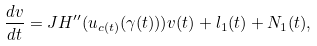Convert formula to latex. <formula><loc_0><loc_0><loc_500><loc_500>\frac { d v } { d t } = J H ^ { \prime \prime } ( u _ { c ( t ) } ( \gamma ( t ) ) ) v ( t ) + l _ { 1 } ( t ) + N _ { 1 } ( t ) ,</formula> 